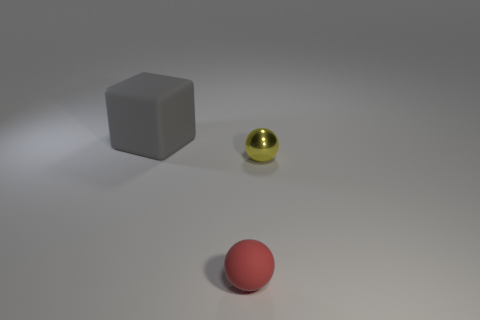Can you describe the overall arrangement and colors of the items in the image? Certainly! In the image, we see three objects arranged on a flat surface with a subtle shadow beneath them, indicating a light source above. Closest to the viewpoint is a red sphere with a matte finish. Behind it and to the left, there's a medium-sized grey cube that also appears to have a matte finish. To the right of the cube and slightly behind the sphere is a small, shiny yellow sphere, reflecting some light and standing out due to its lustrous surface. 